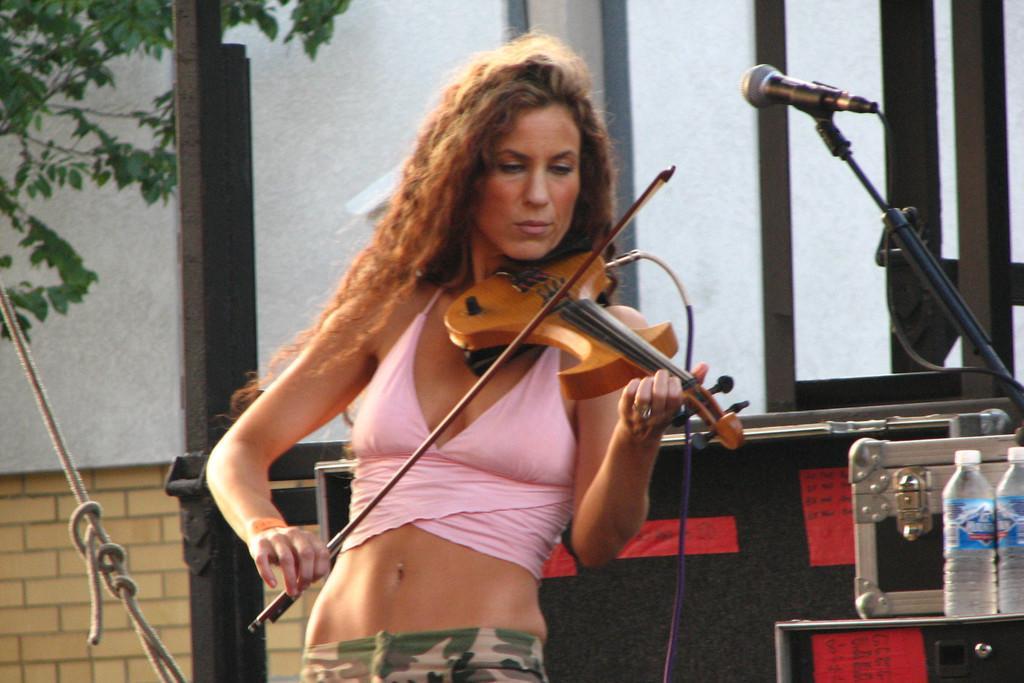Could you give a brief overview of what you see in this image? In the middle of the image a woman is standing and playing violin. Bottom right side of the image there is a microphone and there are some electronic devices and water bottles. Behind her there is a wall. Top left side of the image there is a tree. 